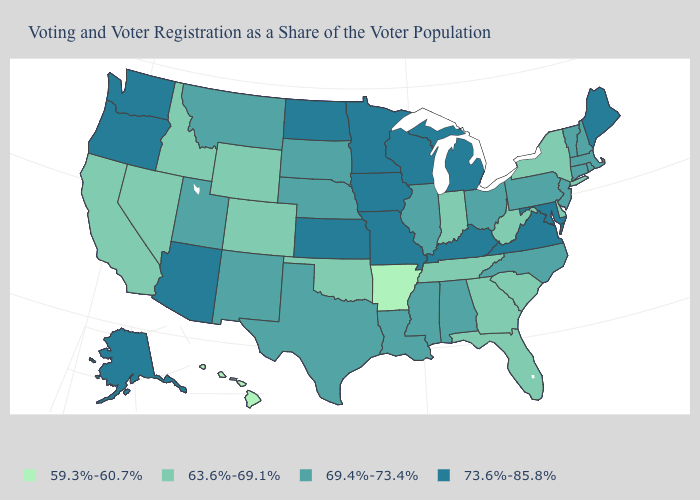Does the map have missing data?
Write a very short answer. No. Does the first symbol in the legend represent the smallest category?
Keep it brief. Yes. What is the value of Missouri?
Concise answer only. 73.6%-85.8%. Among the states that border Virginia , does Kentucky have the highest value?
Short answer required. Yes. Name the states that have a value in the range 63.6%-69.1%?
Concise answer only. California, Colorado, Delaware, Florida, Georgia, Idaho, Indiana, Nevada, New York, Oklahoma, South Carolina, Tennessee, West Virginia, Wyoming. Does the first symbol in the legend represent the smallest category?
Keep it brief. Yes. What is the lowest value in states that border Oklahoma?
Give a very brief answer. 59.3%-60.7%. What is the lowest value in the Northeast?
Short answer required. 63.6%-69.1%. Does Maryland have the highest value in the USA?
Answer briefly. Yes. Which states have the lowest value in the USA?
Give a very brief answer. Arkansas, Hawaii. Among the states that border Minnesota , which have the highest value?
Answer briefly. Iowa, North Dakota, Wisconsin. Name the states that have a value in the range 63.6%-69.1%?
Give a very brief answer. California, Colorado, Delaware, Florida, Georgia, Idaho, Indiana, Nevada, New York, Oklahoma, South Carolina, Tennessee, West Virginia, Wyoming. What is the lowest value in the Northeast?
Answer briefly. 63.6%-69.1%. Name the states that have a value in the range 69.4%-73.4%?
Give a very brief answer. Alabama, Connecticut, Illinois, Louisiana, Massachusetts, Mississippi, Montana, Nebraska, New Hampshire, New Jersey, New Mexico, North Carolina, Ohio, Pennsylvania, Rhode Island, South Dakota, Texas, Utah, Vermont. What is the lowest value in states that border Pennsylvania?
Concise answer only. 63.6%-69.1%. 